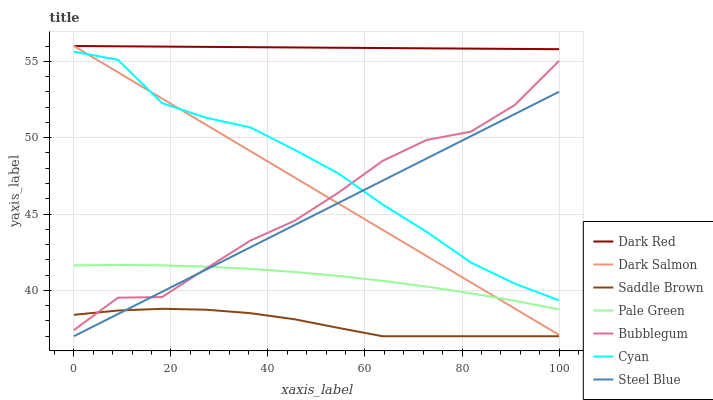Does Saddle Brown have the minimum area under the curve?
Answer yes or no. Yes. Does Dark Red have the maximum area under the curve?
Answer yes or no. Yes. Does Dark Salmon have the minimum area under the curve?
Answer yes or no. No. Does Dark Salmon have the maximum area under the curve?
Answer yes or no. No. Is Dark Red the smoothest?
Answer yes or no. Yes. Is Bubblegum the roughest?
Answer yes or no. Yes. Is Dark Salmon the smoothest?
Answer yes or no. No. Is Dark Salmon the roughest?
Answer yes or no. No. Does Steel Blue have the lowest value?
Answer yes or no. Yes. Does Dark Salmon have the lowest value?
Answer yes or no. No. Does Dark Salmon have the highest value?
Answer yes or no. Yes. Does Bubblegum have the highest value?
Answer yes or no. No. Is Saddle Brown less than Dark Red?
Answer yes or no. Yes. Is Cyan greater than Pale Green?
Answer yes or no. Yes. Does Bubblegum intersect Cyan?
Answer yes or no. Yes. Is Bubblegum less than Cyan?
Answer yes or no. No. Is Bubblegum greater than Cyan?
Answer yes or no. No. Does Saddle Brown intersect Dark Red?
Answer yes or no. No. 